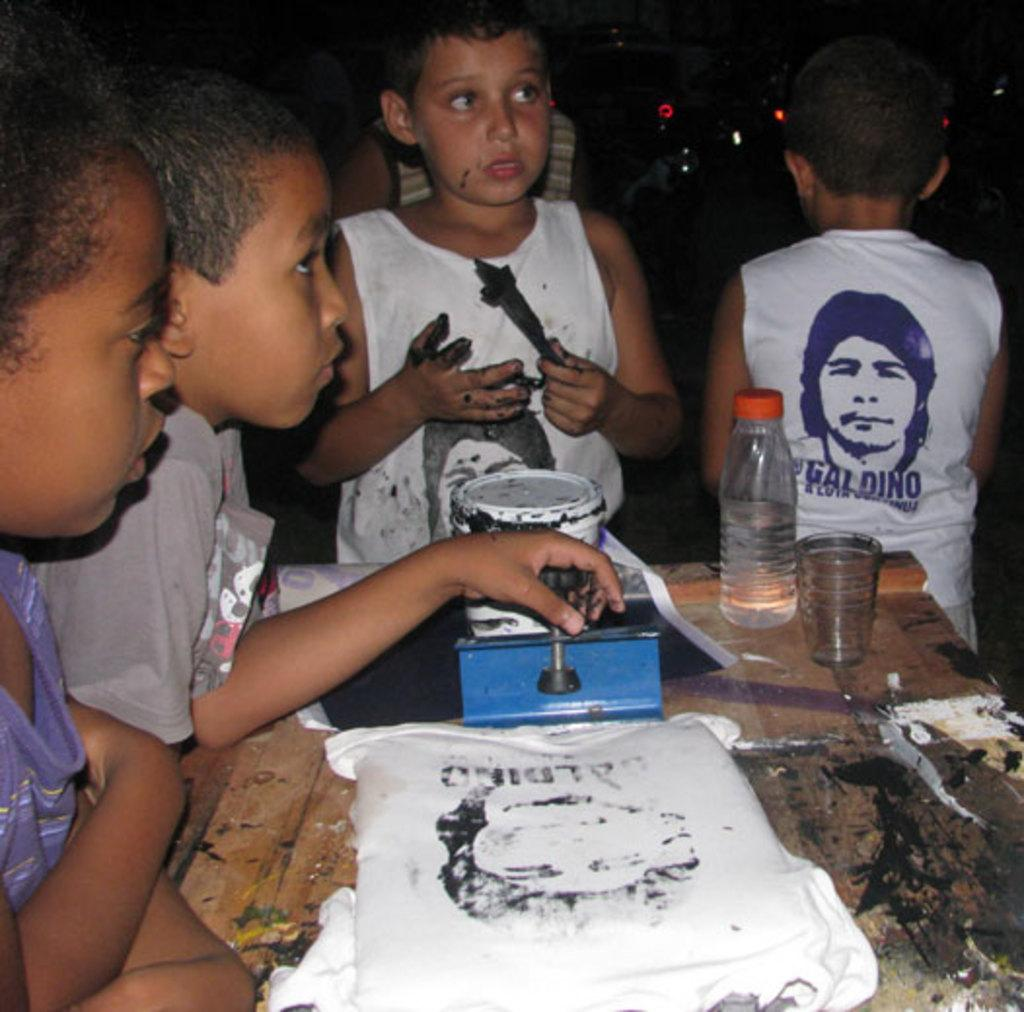Who is present in the image? There are kids in the image. What can be seen on a table in the image? There is a glass, a bottle, and other objects on a table in the image. What might be used for painting in the image? There is a painting box in the image. What can be seen in the background of the image? There are lights visible in the background of the image. Can you tell me how the dock is used in the image? There is no dock present in the image. What type of instrument is being played by the kids in the image? The image does not show the kids playing any instruments. 